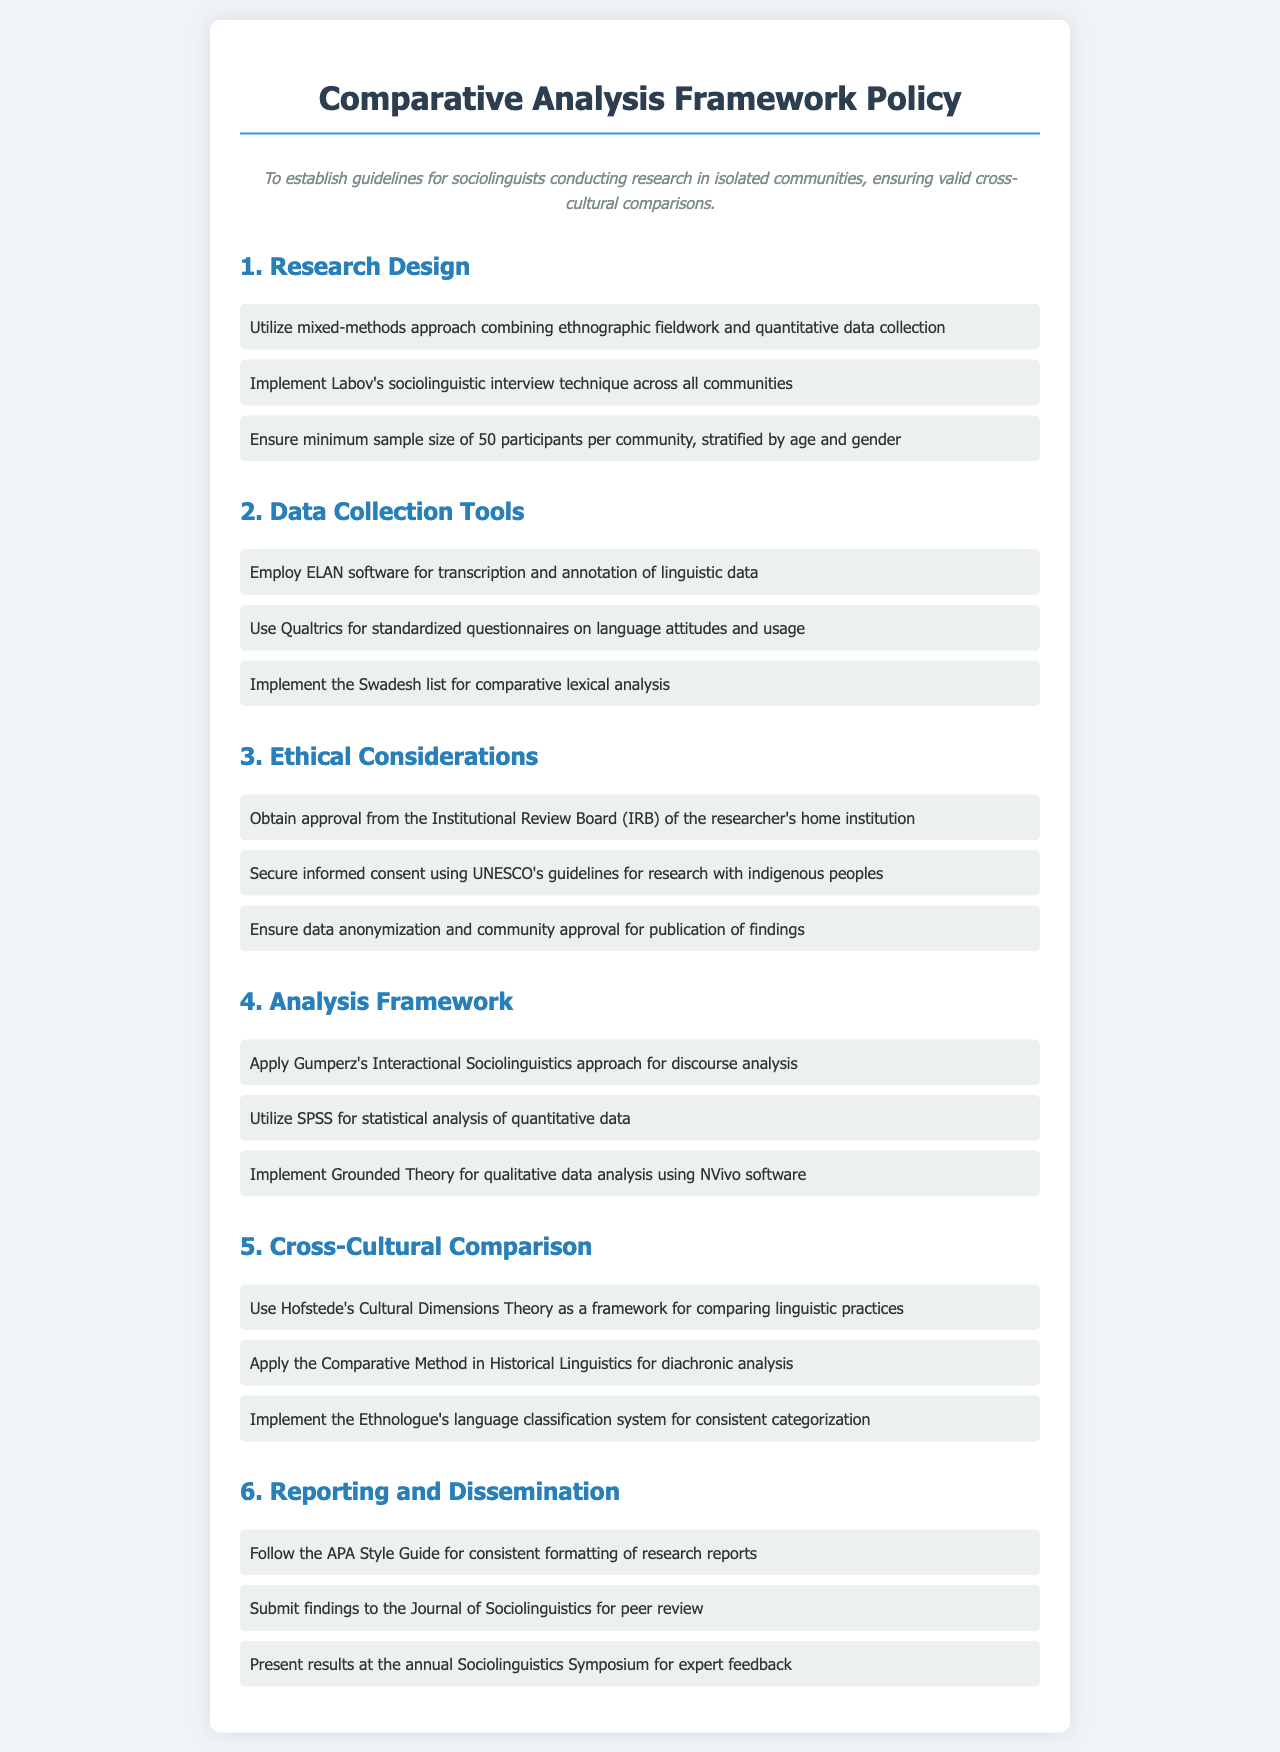What is the minimum sample size per community? The document states that the minimum sample size must be 50 participants per community.
Answer: 50 participants What software is used for transcription and annotation? The document specifies the use of ELAN software for this purpose.
Answer: ELAN Which ethical guideline is mentioned for securing informed consent? The document refers to UNESCO's guidelines for research with indigenous peoples.
Answer: UNESCO's guidelines What analysis approach is applied for discourse analysis? The document states that Gumperz's Interactional Sociolinguistics approach is used for discourse analysis.
Answer: Gumperz's Interactional Sociolinguistics What classification system is implemented for consistent categorization? The document mentions the Ethnologue's language classification system for this purpose.
Answer: Ethnologue's language classification system What method is suggested for qualitative data analysis? The document indicates the use of Grounded Theory for qualitative data analysis.
Answer: Grounded Theory Which theory is used as a framework for comparing linguistic practices? The document states that Hofstede's Cultural Dimensions Theory serves as the framework.
Answer: Hofstede's Cultural Dimensions Theory What is the primary focus of the Comparative Analysis Framework Policy? The document outlines guidelines for sociolinguists ensuring valid cross-cultural comparisons.
Answer: Valid cross-cultural comparisons 